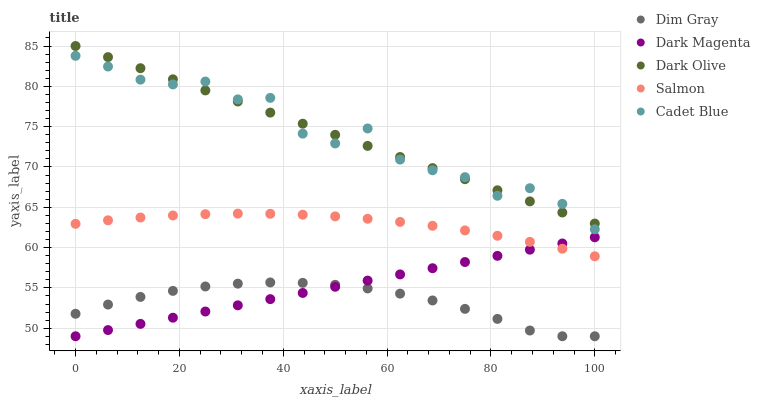Does Dim Gray have the minimum area under the curve?
Answer yes or no. Yes. Does Cadet Blue have the maximum area under the curve?
Answer yes or no. Yes. Does Salmon have the minimum area under the curve?
Answer yes or no. No. Does Salmon have the maximum area under the curve?
Answer yes or no. No. Is Dark Magenta the smoothest?
Answer yes or no. Yes. Is Cadet Blue the roughest?
Answer yes or no. Yes. Is Dim Gray the smoothest?
Answer yes or no. No. Is Dim Gray the roughest?
Answer yes or no. No. Does Dim Gray have the lowest value?
Answer yes or no. Yes. Does Salmon have the lowest value?
Answer yes or no. No. Does Dark Olive have the highest value?
Answer yes or no. Yes. Does Salmon have the highest value?
Answer yes or no. No. Is Dim Gray less than Salmon?
Answer yes or no. Yes. Is Dark Olive greater than Salmon?
Answer yes or no. Yes. Does Dark Olive intersect Cadet Blue?
Answer yes or no. Yes. Is Dark Olive less than Cadet Blue?
Answer yes or no. No. Is Dark Olive greater than Cadet Blue?
Answer yes or no. No. Does Dim Gray intersect Salmon?
Answer yes or no. No. 